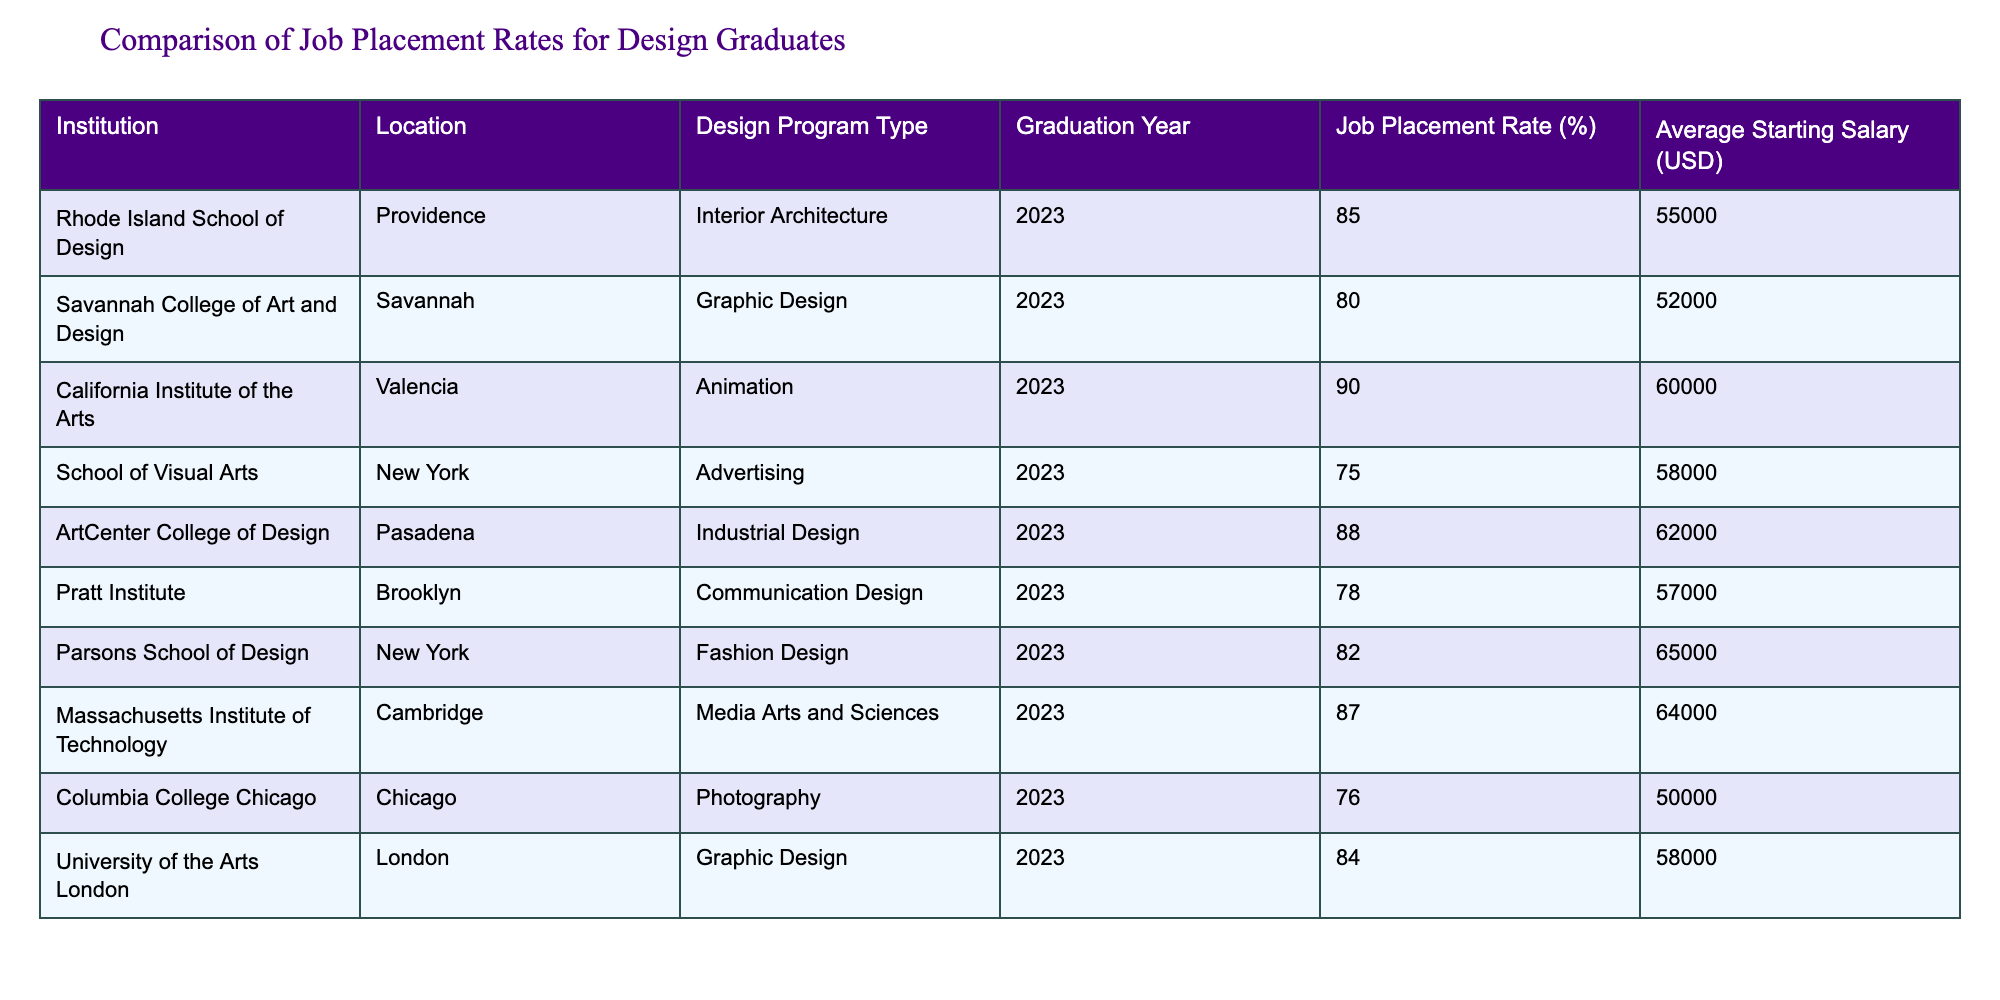What is the highest job placement rate among the institutions listed? The table shows the job placement rates for various institutions. To find the highest rate, I will compare all the values in the "Job Placement Rate (%)" column. The highest value is 90% from the California Institute of the Arts.
Answer: 90% Which institution has the lowest average starting salary? By examining the "Average Starting Salary (USD)" column, the lowest value here is $50,000 from Columbia College Chicago.
Answer: $50,000 What is the average job placement rate for all the institutions? To calculate the average job placement rate, I will sum up all the job placement rates: 85 + 80 + 90 + 75 + 88 + 78 + 82 + 87 + 76 + 84 =  834. There are 10 institutions, so the average is 834 / 10 = 83.4%.
Answer: 83.4% Is the average starting salary for Fashion Design graduates higher than 60000 USD? The average starting salary for Fashion Design graduates from the Parsons School of Design is 65000 USD, which is indeed higher than 60000 USD.
Answer: Yes Which program has the second highest job placement rate, and what is that rate? First, we identify the job placement rates in descending order: 90%, 88%, 87%, 85%, and so on. The second highest rate is 88%, which is the job placement rate for Industrial Design at ArtCenter College of Design.
Answer: 88% 